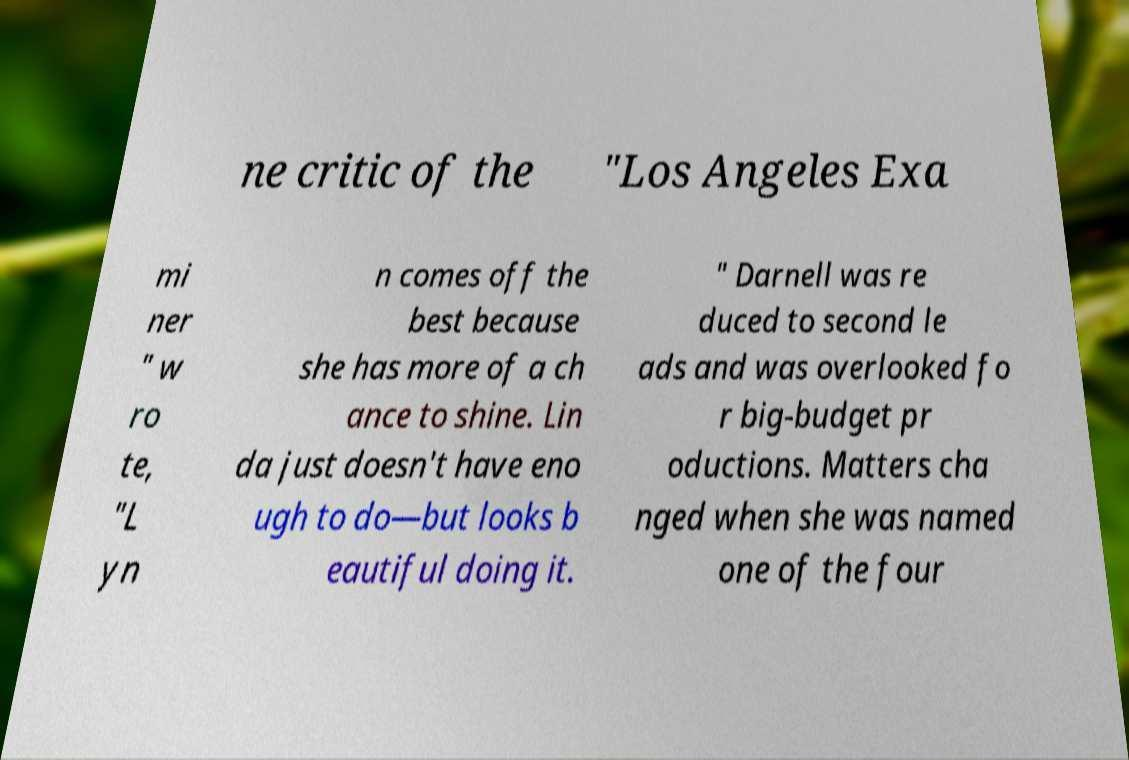What messages or text are displayed in this image? I need them in a readable, typed format. ne critic of the "Los Angeles Exa mi ner " w ro te, "L yn n comes off the best because she has more of a ch ance to shine. Lin da just doesn't have eno ugh to do—but looks b eautiful doing it. " Darnell was re duced to second le ads and was overlooked fo r big-budget pr oductions. Matters cha nged when she was named one of the four 